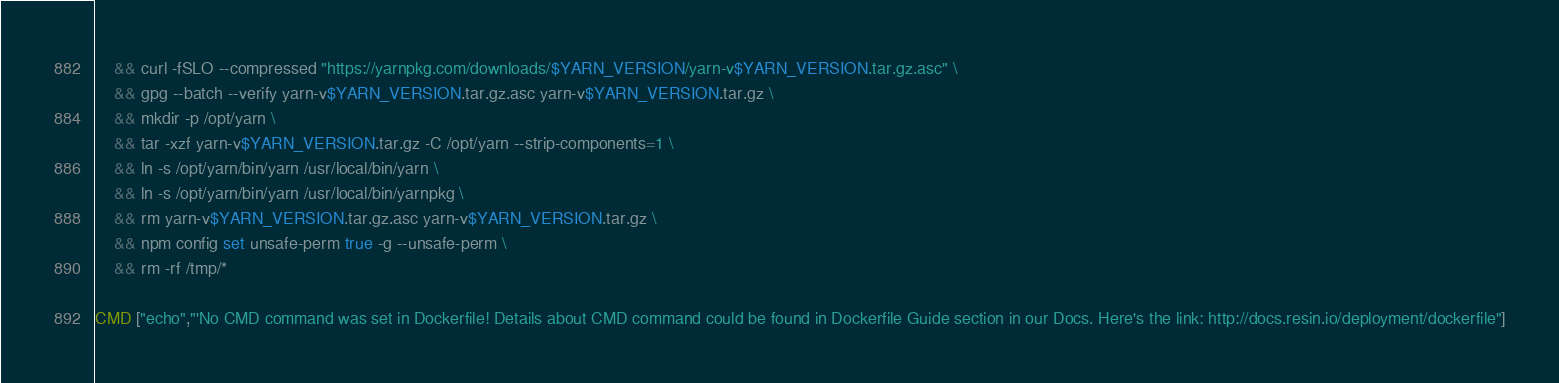Convert code to text. <code><loc_0><loc_0><loc_500><loc_500><_Dockerfile_>	&& curl -fSLO --compressed "https://yarnpkg.com/downloads/$YARN_VERSION/yarn-v$YARN_VERSION.tar.gz.asc" \
	&& gpg --batch --verify yarn-v$YARN_VERSION.tar.gz.asc yarn-v$YARN_VERSION.tar.gz \
	&& mkdir -p /opt/yarn \
	&& tar -xzf yarn-v$YARN_VERSION.tar.gz -C /opt/yarn --strip-components=1 \
	&& ln -s /opt/yarn/bin/yarn /usr/local/bin/yarn \
	&& ln -s /opt/yarn/bin/yarn /usr/local/bin/yarnpkg \
	&& rm yarn-v$YARN_VERSION.tar.gz.asc yarn-v$YARN_VERSION.tar.gz \
	&& npm config set unsafe-perm true -g --unsafe-perm \
	&& rm -rf /tmp/*

CMD ["echo","'No CMD command was set in Dockerfile! Details about CMD command could be found in Dockerfile Guide section in our Docs. Here's the link: http://docs.resin.io/deployment/dockerfile"]
</code> 